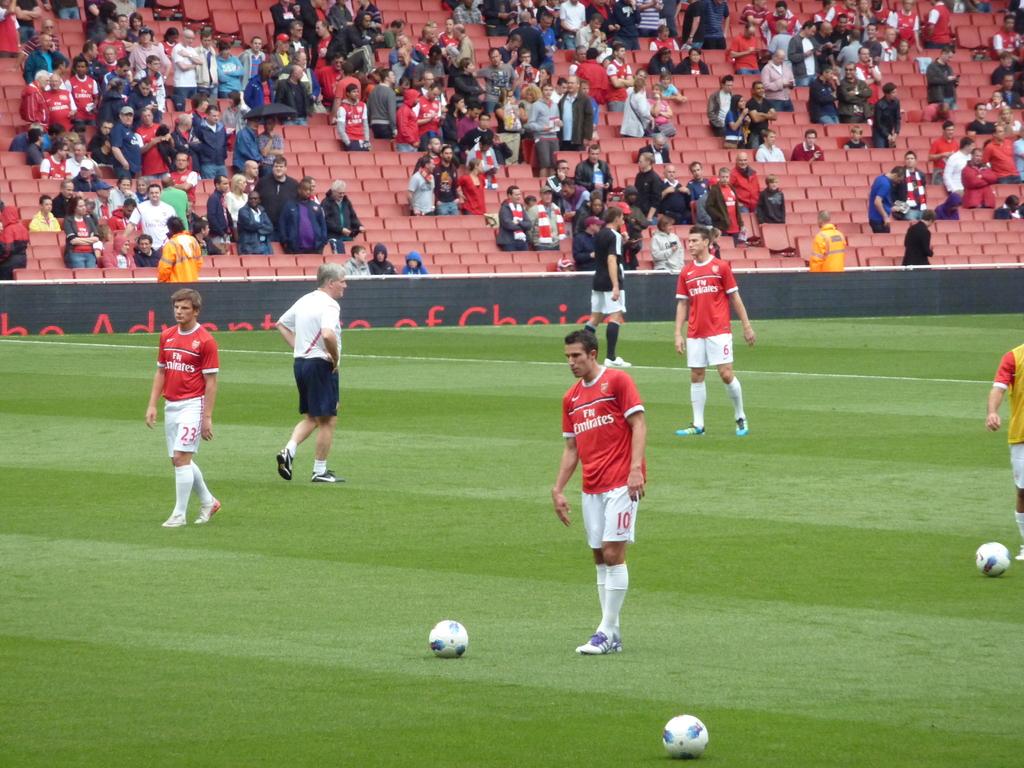Who do the red team play for?
Offer a terse response. Fly emirates. 